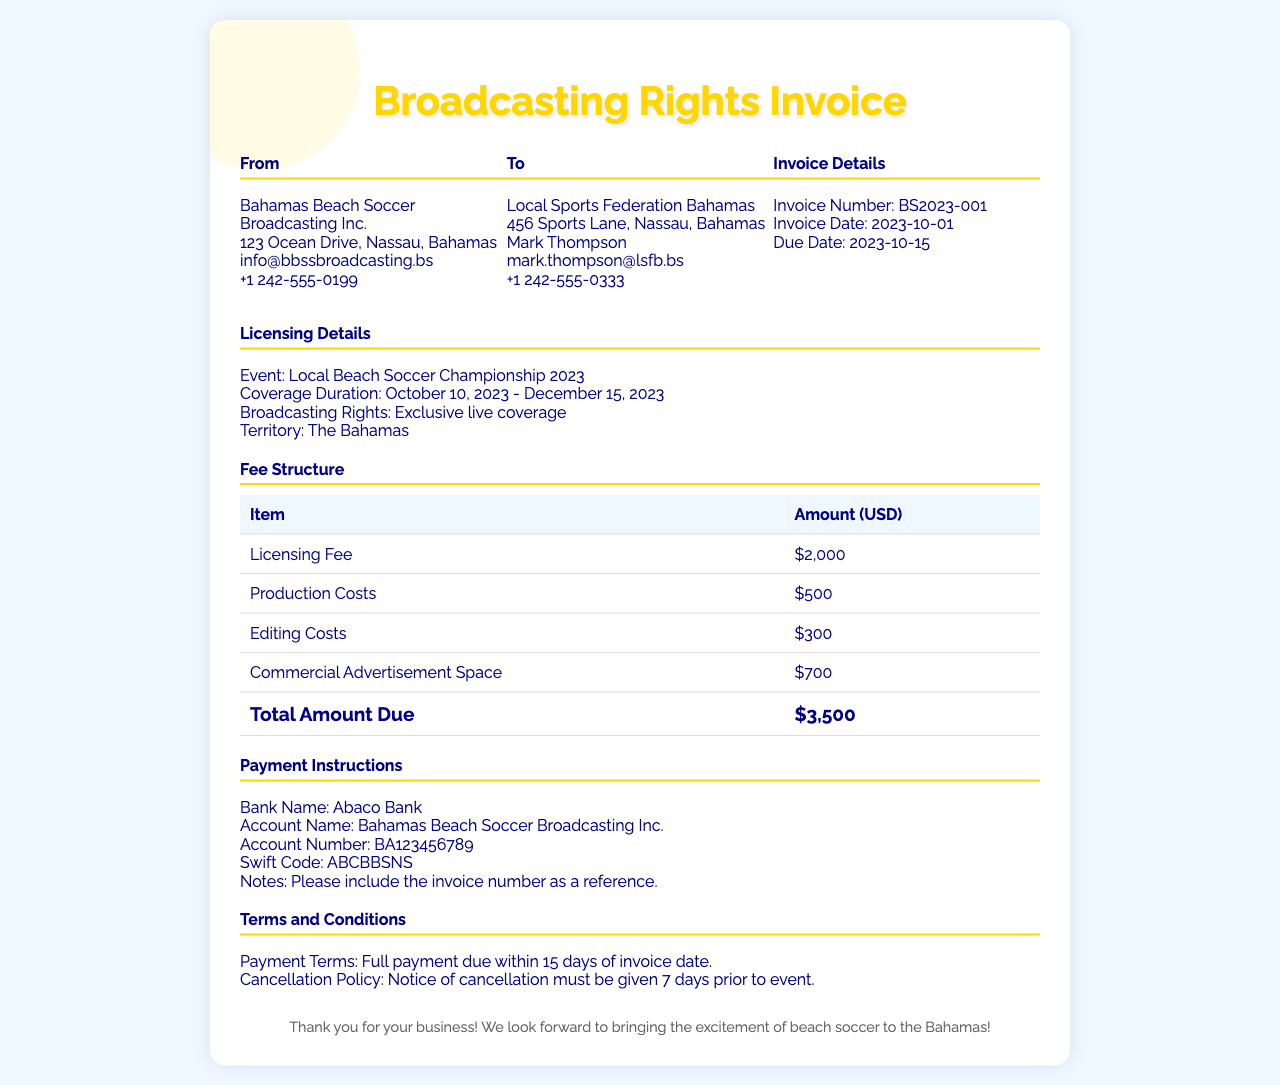what is the invoice number? The invoice number is listed in the invoice details section.
Answer: BS2023-001 what is the total amount due? The total amount due is found in the fee structure section, summing up all charges.
Answer: $3,500 who is the recipient of the invoice? The recipient's name and organization are specified in the "To" section.
Answer: Local Sports Federation Bahamas what is the coverage duration? The coverage duration is specified in the licensing details section.
Answer: October 10, 2023 - December 15, 2023 what is the licensing fee? The licensing fee is detailed in the fee structure section.
Answer: $2,000 what is the payment term? This information is specified under "Terms and Conditions."
Answer: Full payment due within 15 days of invoice date which bank should the payment go to? The bank information is found in the payment instructions section.
Answer: Abaco Bank what type of coverage is provided? The type of coverage is mentioned in the licensing details section.
Answer: Exclusive live coverage what is the cancellation policy? This policy is described in the terms and conditions section of the invoice.
Answer: Notice of cancellation must be given 7 days prior to event 